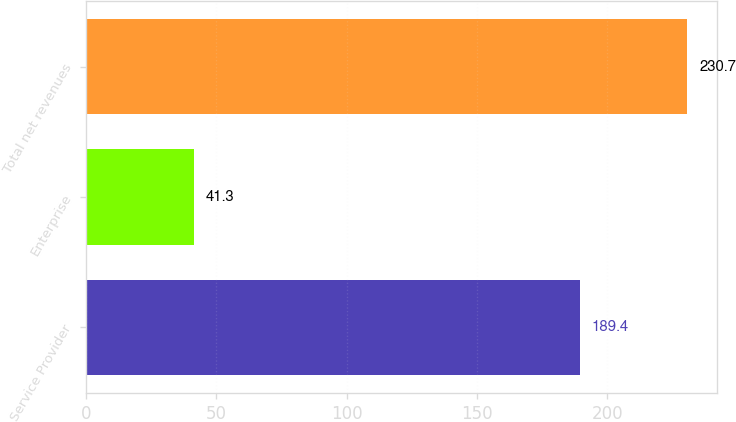Convert chart to OTSL. <chart><loc_0><loc_0><loc_500><loc_500><bar_chart><fcel>Service Provider<fcel>Enterprise<fcel>Total net revenues<nl><fcel>189.4<fcel>41.3<fcel>230.7<nl></chart> 